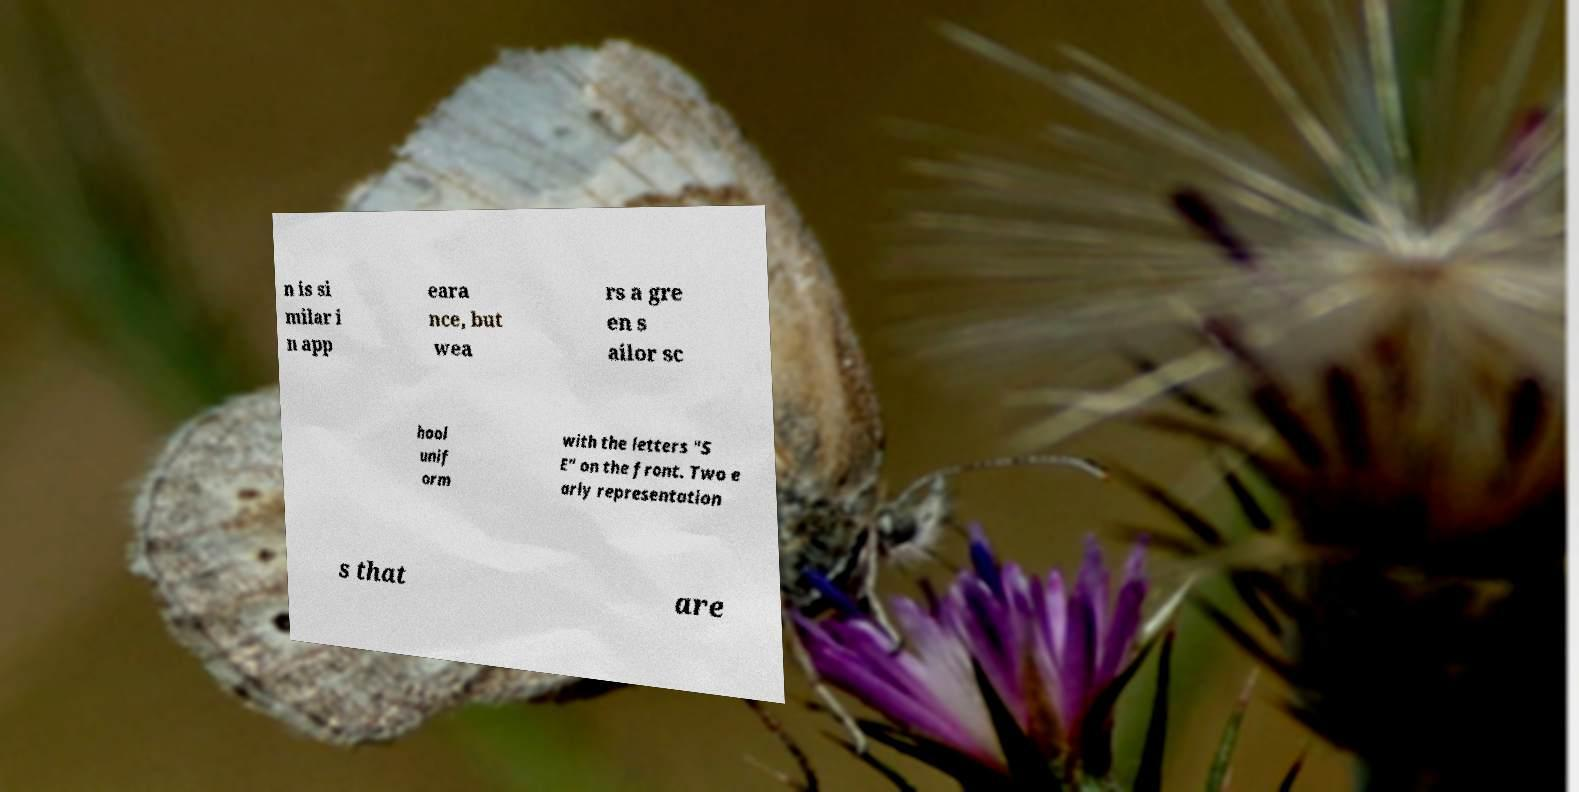Could you extract and type out the text from this image? n is si milar i n app eara nce, but wea rs a gre en s ailor sc hool unif orm with the letters "S E" on the front. Two e arly representation s that are 